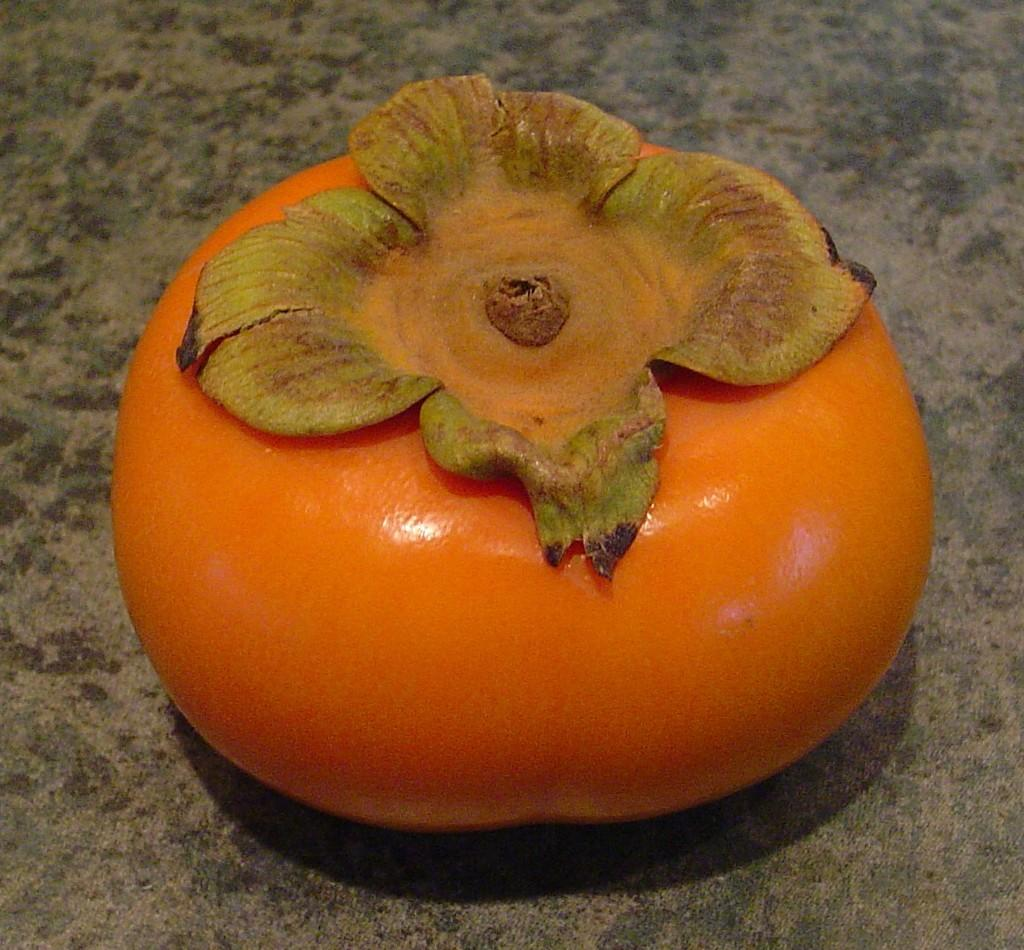What type of fruit is present in the image? There is a Persimmon in the image. What is the color of the Persimmon? The Persimmon is orange in color. What theory is being discussed by the rabbits in the image? There are no rabbits present in the image, and therefore no discussion or theory can be observed. 